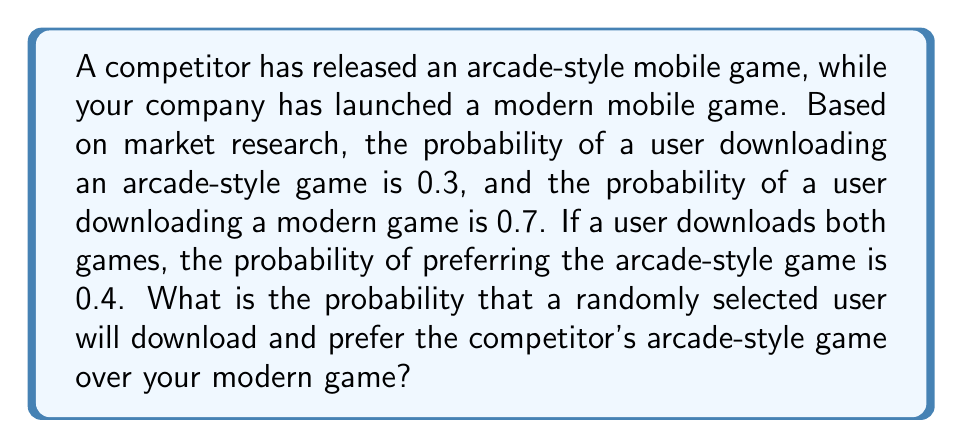Solve this math problem. Let's approach this step-by-step:

1) Let A be the event of downloading the arcade-style game
   Let M be the event of downloading the modern game
   Let P be the event of preferring the arcade-style game

2) Given:
   P(A) = 0.3
   P(M) = 0.7
   P(P|A∩M) = 0.4 (probability of preferring arcade-style given both are downloaded)

3) We need to find P(A ∩ P), which can be calculated using the law of total probability:

   P(A ∩ P) = P(A ∩ P ∩ M) + P(A ∩ P ∩ M')

4) First, let's calculate P(A ∩ P ∩ M):
   P(A ∩ P ∩ M) = P(A) * P(M) * P(P|A∩M)
                 = 0.3 * 0.7 * 0.4
                 = 0.084

5) Now, for P(A ∩ P ∩ M'), we assume that if only the arcade-style game is downloaded, it will be preferred:
   P(A ∩ P ∩ M') = P(A) * P(M')
                  = 0.3 * (1 - 0.7)
                  = 0.3 * 0.3
                  = 0.09

6) Adding these probabilities:
   P(A ∩ P) = 0.084 + 0.09 = 0.174

Therefore, the probability that a randomly selected user will download and prefer the competitor's arcade-style game is 0.174 or 17.4%.
Answer: 0.174 